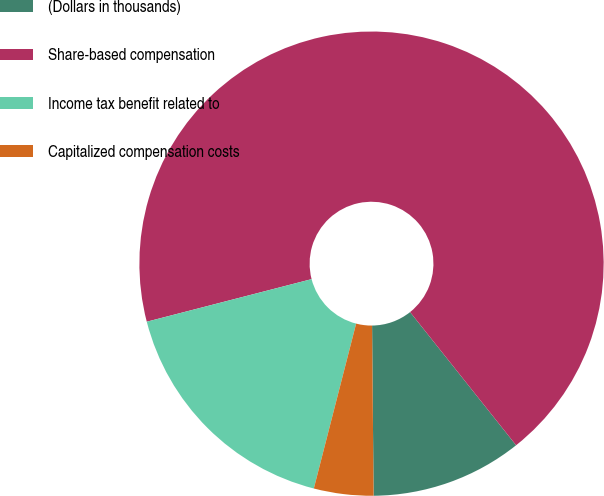Convert chart to OTSL. <chart><loc_0><loc_0><loc_500><loc_500><pie_chart><fcel>(Dollars in thousands)<fcel>Share-based compensation<fcel>Income tax benefit related to<fcel>Capitalized compensation costs<nl><fcel>10.56%<fcel>68.33%<fcel>16.98%<fcel>4.14%<nl></chart> 